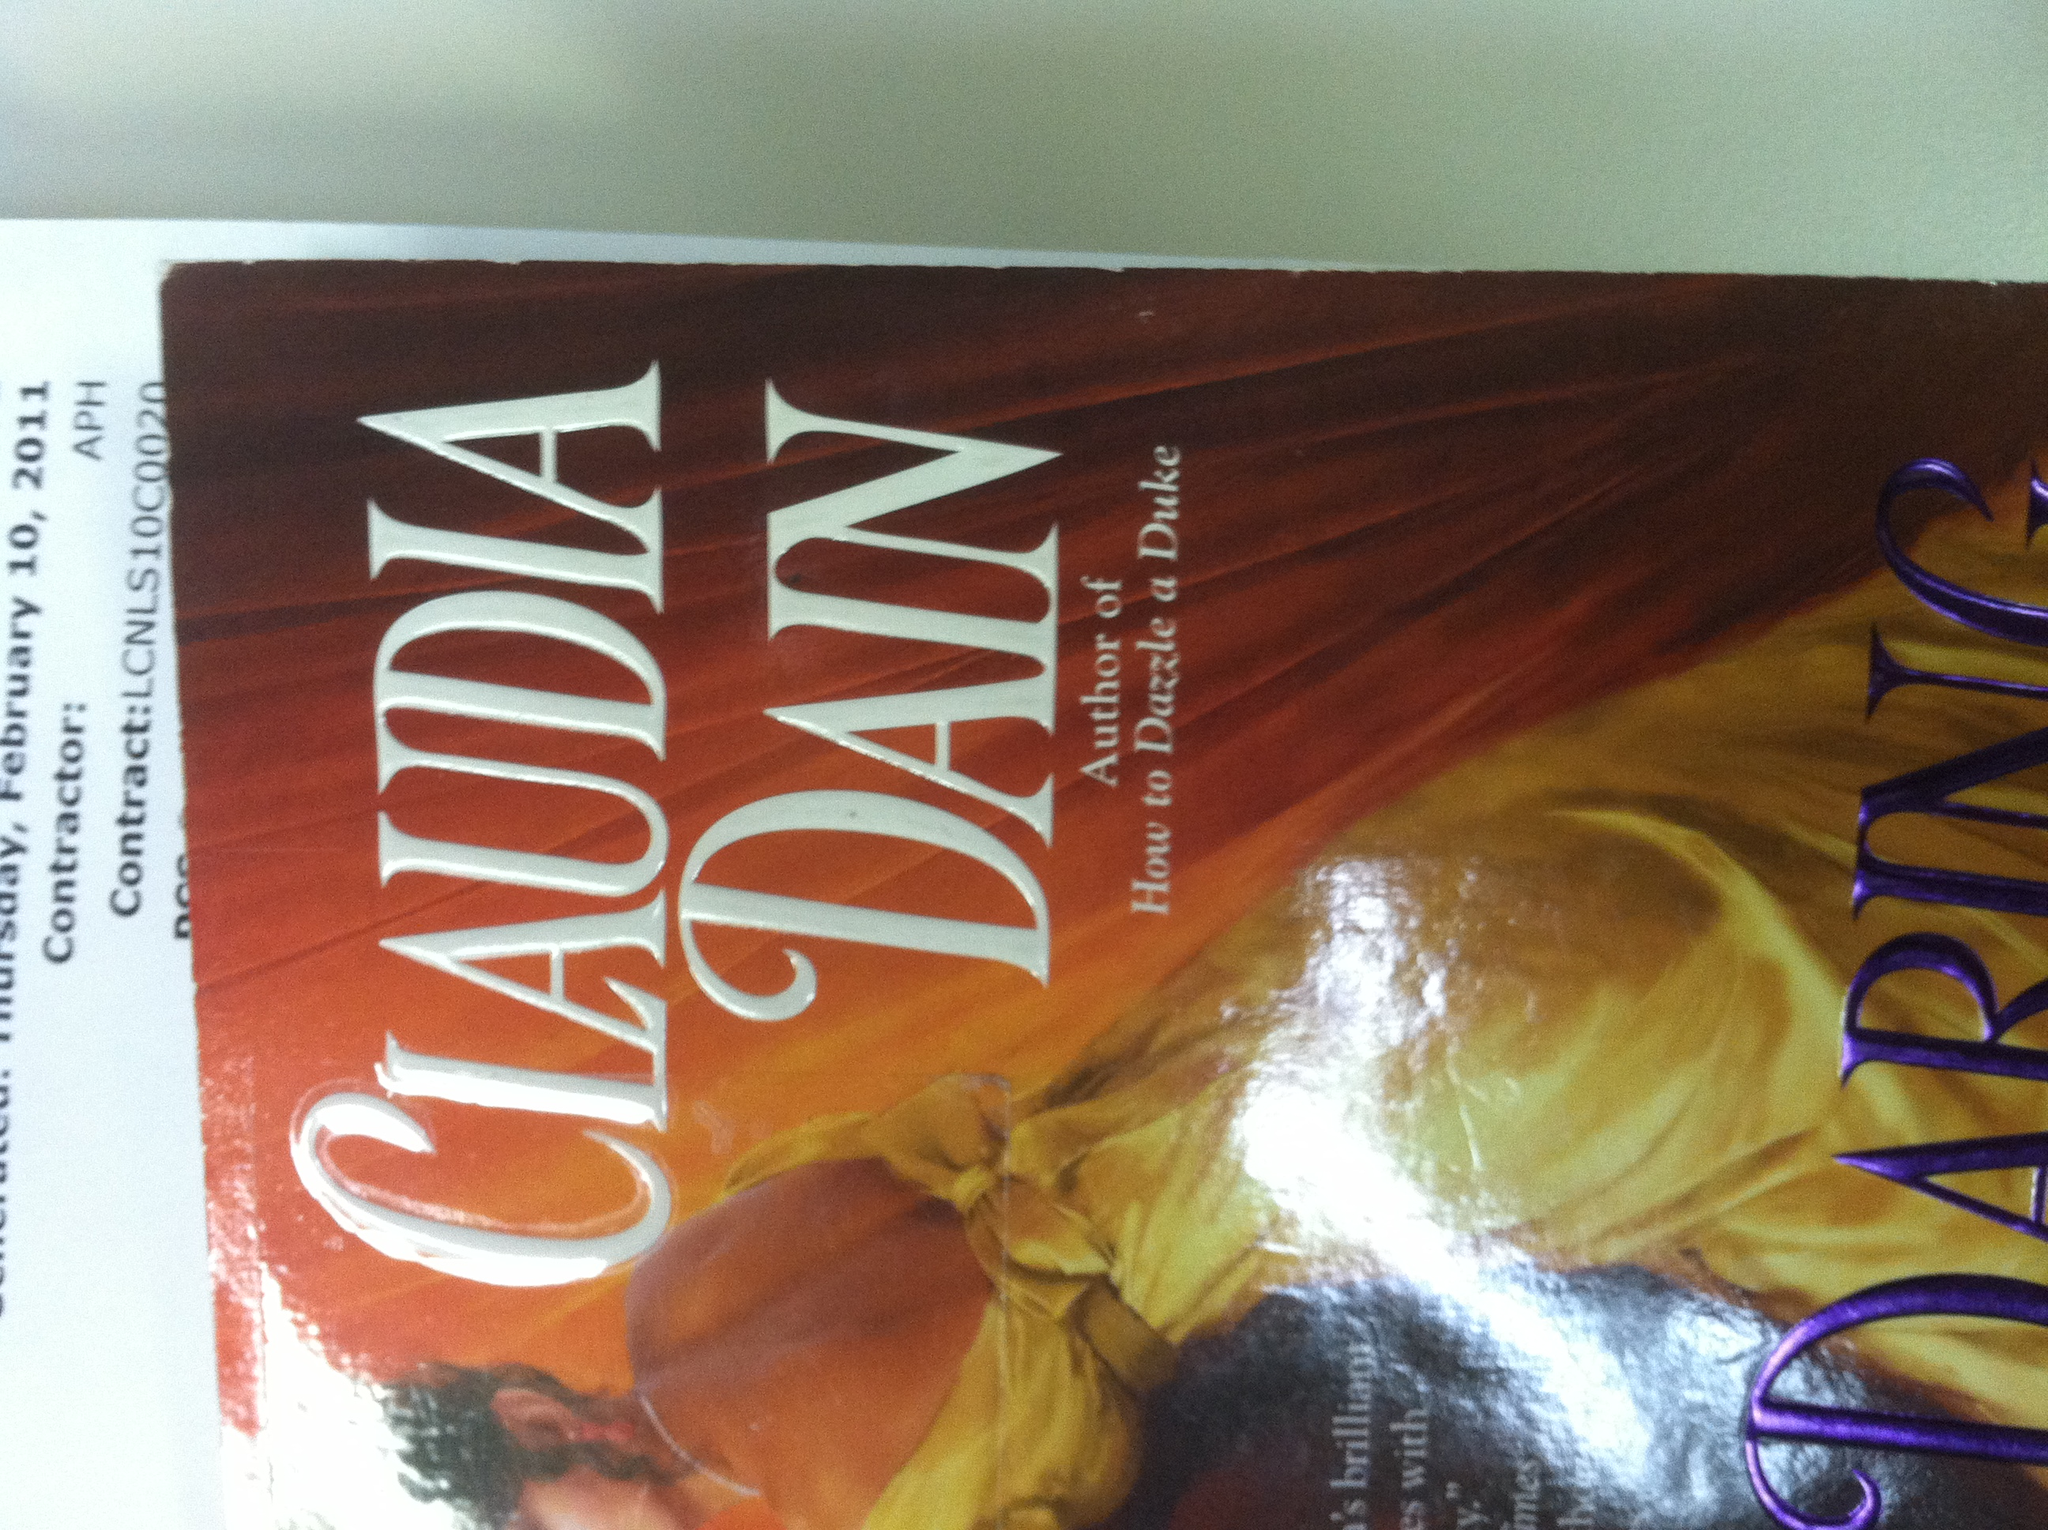What genre does this book belong to? The book 'Daring' by Claudia Dain likely belongs to the historical romance genre, as indicated by its cover design and the author's noted history of writing in this category. 